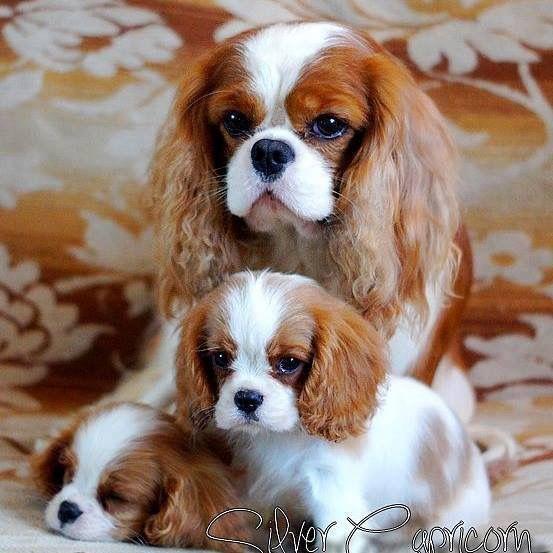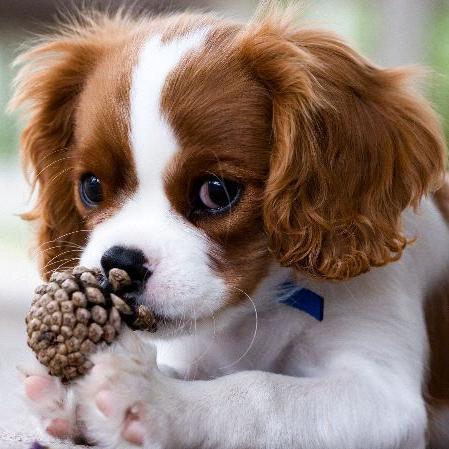The first image is the image on the left, the second image is the image on the right. Given the left and right images, does the statement "At least one image shows a dog with a dog tag." hold true? Answer yes or no. No. 